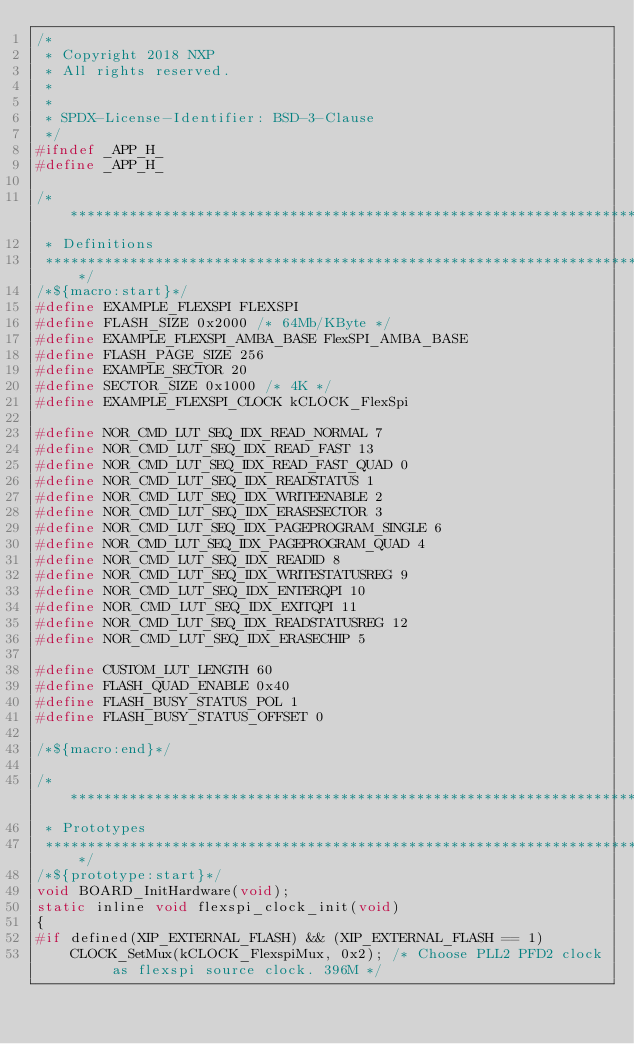Convert code to text. <code><loc_0><loc_0><loc_500><loc_500><_C_>/*
 * Copyright 2018 NXP
 * All rights reserved.
 *
 *
 * SPDX-License-Identifier: BSD-3-Clause
 */
#ifndef _APP_H_
#define _APP_H_

/*******************************************************************************
 * Definitions
 ******************************************************************************/
/*${macro:start}*/
#define EXAMPLE_FLEXSPI FLEXSPI
#define FLASH_SIZE 0x2000 /* 64Mb/KByte */
#define EXAMPLE_FLEXSPI_AMBA_BASE FlexSPI_AMBA_BASE
#define FLASH_PAGE_SIZE 256
#define EXAMPLE_SECTOR 20
#define SECTOR_SIZE 0x1000 /* 4K */
#define EXAMPLE_FLEXSPI_CLOCK kCLOCK_FlexSpi

#define NOR_CMD_LUT_SEQ_IDX_READ_NORMAL 7
#define NOR_CMD_LUT_SEQ_IDX_READ_FAST 13
#define NOR_CMD_LUT_SEQ_IDX_READ_FAST_QUAD 0
#define NOR_CMD_LUT_SEQ_IDX_READSTATUS 1
#define NOR_CMD_LUT_SEQ_IDX_WRITEENABLE 2
#define NOR_CMD_LUT_SEQ_IDX_ERASESECTOR 3
#define NOR_CMD_LUT_SEQ_IDX_PAGEPROGRAM_SINGLE 6
#define NOR_CMD_LUT_SEQ_IDX_PAGEPROGRAM_QUAD 4
#define NOR_CMD_LUT_SEQ_IDX_READID 8
#define NOR_CMD_LUT_SEQ_IDX_WRITESTATUSREG 9
#define NOR_CMD_LUT_SEQ_IDX_ENTERQPI 10
#define NOR_CMD_LUT_SEQ_IDX_EXITQPI 11
#define NOR_CMD_LUT_SEQ_IDX_READSTATUSREG 12
#define NOR_CMD_LUT_SEQ_IDX_ERASECHIP 5

#define CUSTOM_LUT_LENGTH 60
#define FLASH_QUAD_ENABLE 0x40
#define FLASH_BUSY_STATUS_POL 1
#define FLASH_BUSY_STATUS_OFFSET 0

/*${macro:end}*/

/*******************************************************************************
 * Prototypes
 ******************************************************************************/
/*${prototype:start}*/
void BOARD_InitHardware(void);
static inline void flexspi_clock_init(void)
{
#if defined(XIP_EXTERNAL_FLASH) && (XIP_EXTERNAL_FLASH == 1)
    CLOCK_SetMux(kCLOCK_FlexspiMux, 0x2); /* Choose PLL2 PFD2 clock as flexspi source clock. 396M */</code> 